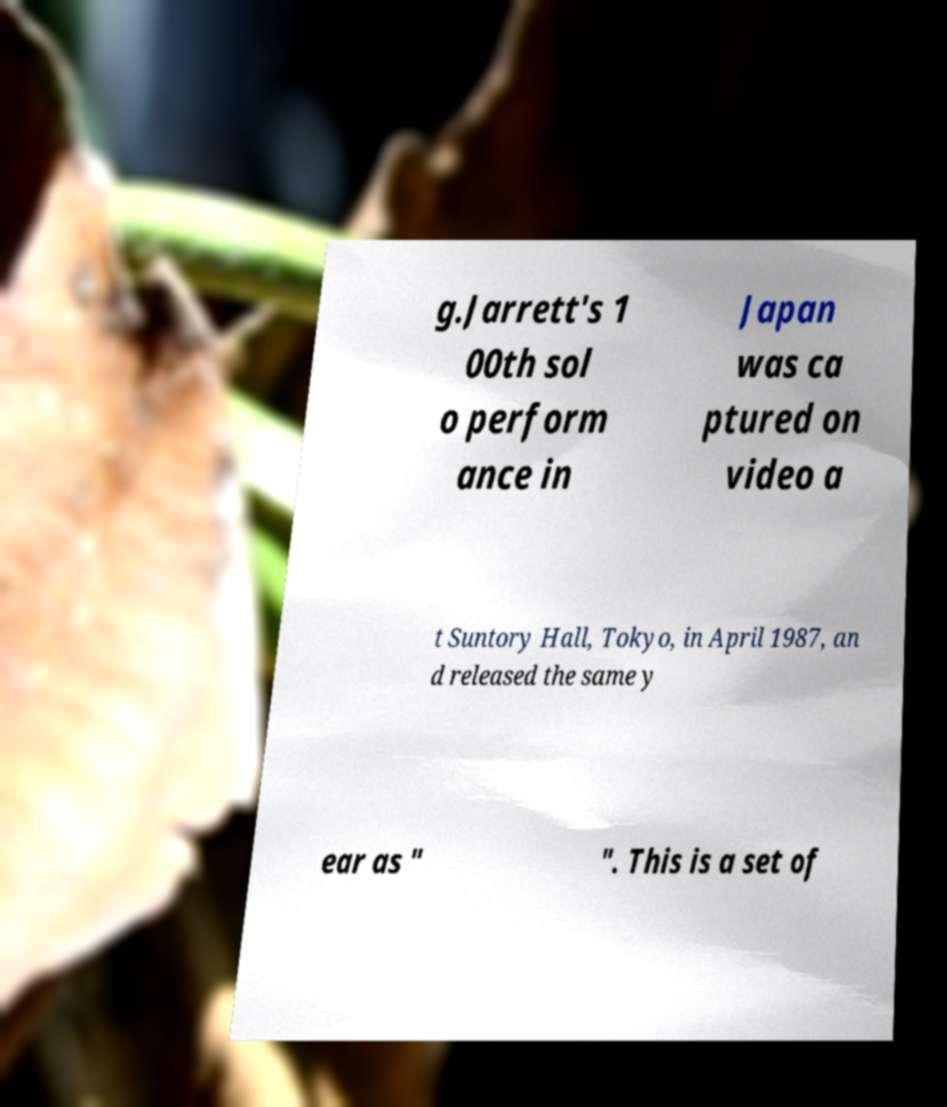Could you extract and type out the text from this image? g.Jarrett's 1 00th sol o perform ance in Japan was ca ptured on video a t Suntory Hall, Tokyo, in April 1987, an d released the same y ear as " ". This is a set of 